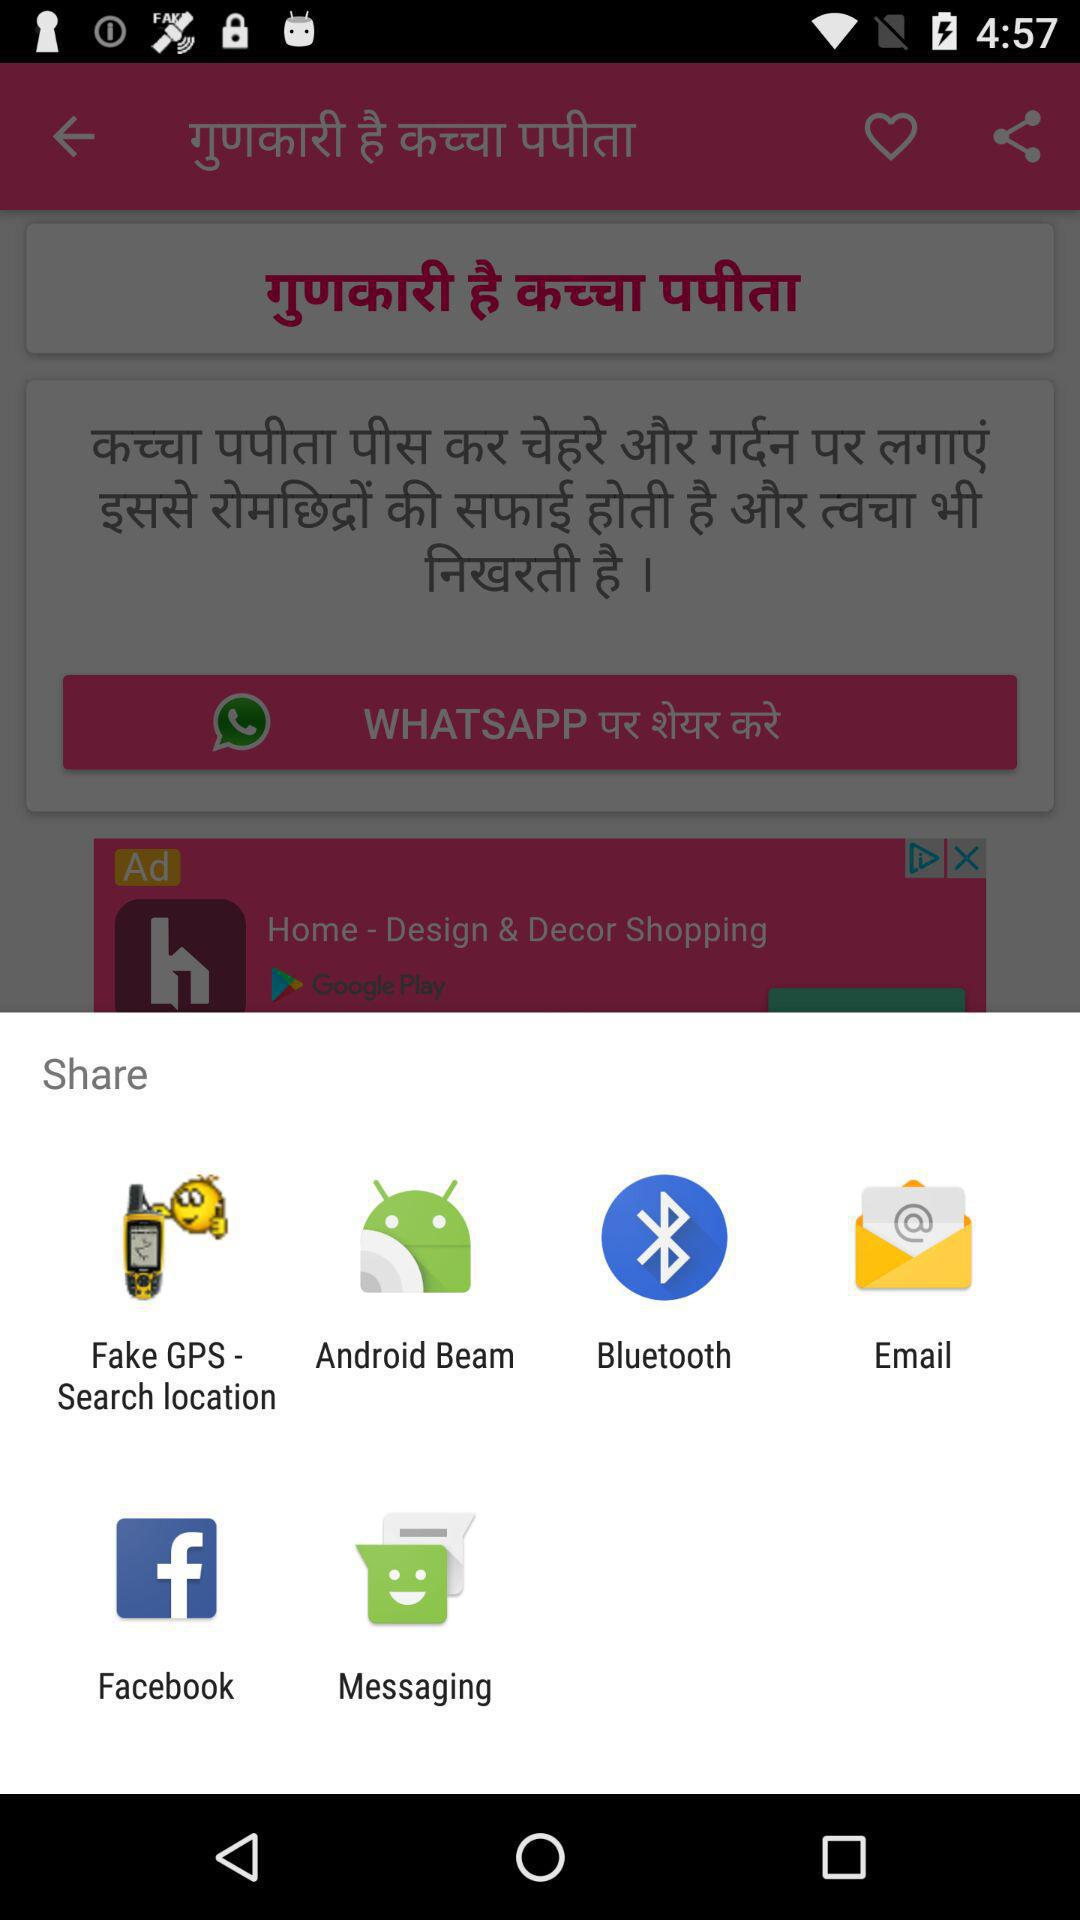What are the different options available to share an invite? The different options available to share an invite are "Fake GPS - Search location", "Android Beam", "Bluetooth", "Email", "Facebook" and "Messaging". 